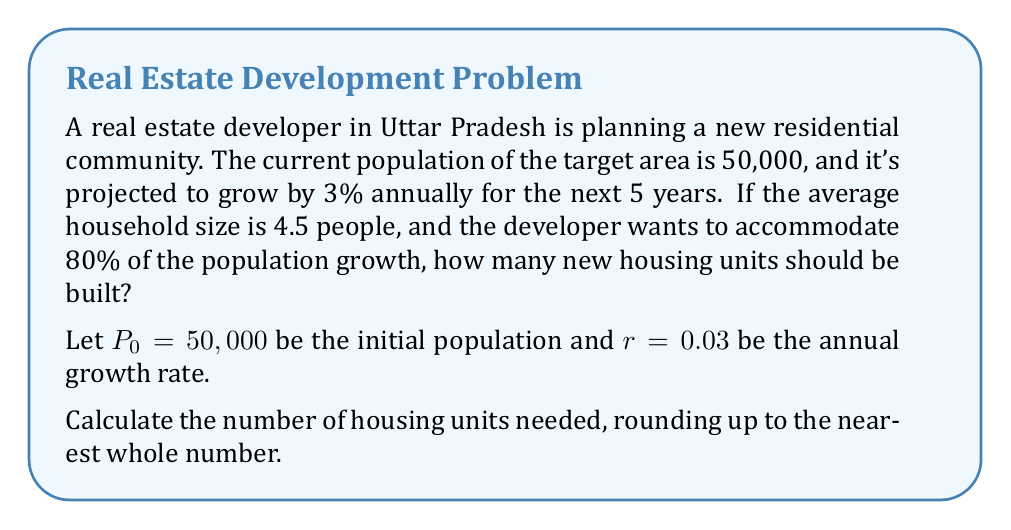Can you answer this question? Let's approach this step-by-step:

1) First, we need to calculate the population after 5 years. The formula for compound growth is:

   $$P_5 = P_0(1 + r)^5$$

   Where $P_5$ is the population after 5 years, $P_0$ is the initial population, $r$ is the annual growth rate, and 5 is the number of years.

2) Plugging in our values:

   $$P_5 = 50,000(1 + 0.03)^5 = 50,000(1.03)^5 = 57,963.75$$

3) Now, we calculate the population growth:

   $$\text{Growth} = P_5 - P_0 = 57,963.75 - 50,000 = 7,963.75$$

4) The developer wants to accommodate 80% of this growth:

   $$\text{Accommodation needed} = 7,963.75 \times 0.80 = 6,371$$

5) To find the number of housing units, we divide by the average household size:

   $$\text{Housing units} = \frac{6,371}{4.5} = 1,415.78$$

6) Rounding up to the nearest whole number:

   $$\text{Housing units needed} = 1,416$$
Answer: 1,416 housing units 